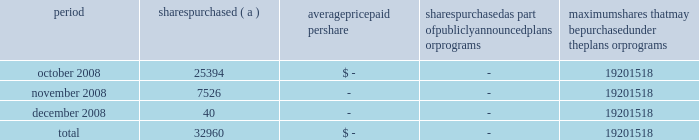Annual report on form 10-k 108 fifth third bancorp part ii item 5 .
Market for registrant 2019s common equity , related stockholder matters and issuer purchases of equity securities the information required by this item is included in the corporate information found on the inside of the back cover and in the discussion of dividend limitations that the subsidiaries can pay to the bancorp discussed in note 26 of the notes to the consolidated financial statements .
Additionally , as of december 31 , 2008 , the bancorp had approximately 60025 shareholders of record .
Issuer purchases of equity securities period shares purchased average paid per shares purchased as part of publicly announced plans or programs maximum shares that may be purchased under the plans or programs .
( a ) the bancorp repurchased 25394 , 7526 and 40 shares during october , november and december of 2008 in connection with various employee compensation plans of the bancorp .
These purchases are not included against the maximum number of shares that may yet be purchased under the board of directors authorization. .
What percentage of the fourth quarter share repurchases were in the last moth of the year in 2008? 
Computations: (40 / 32960)
Answer: 0.00121. 